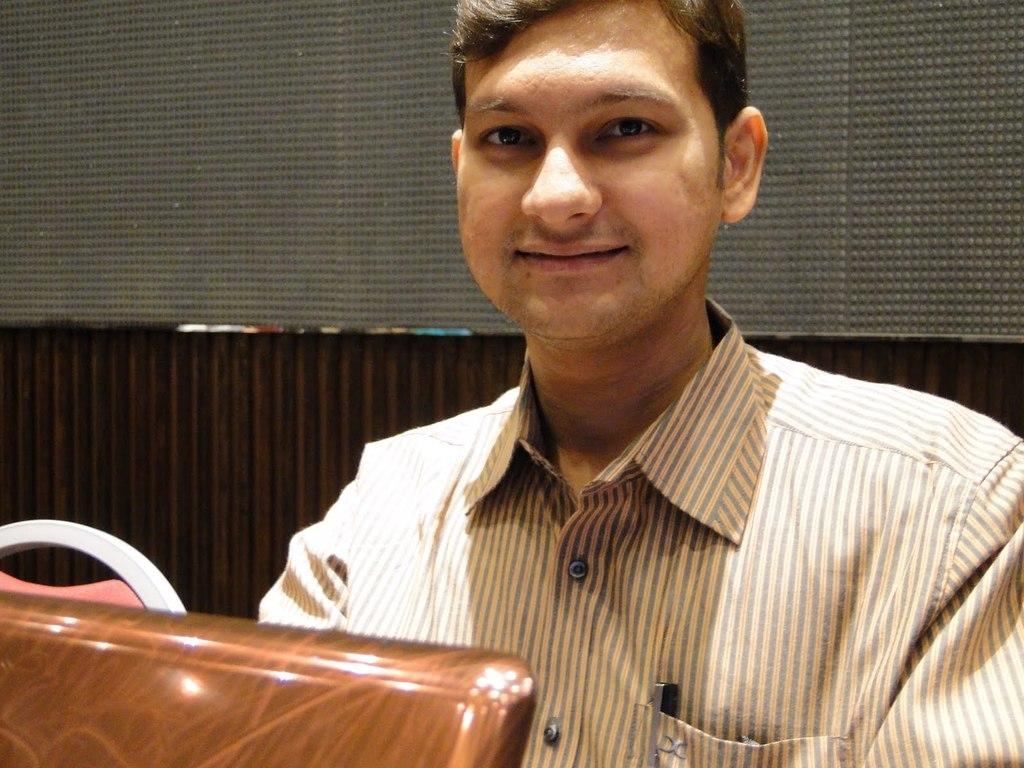What is the main subject of the image? The main subject of the image is a man sitting in a close-up picture. What can be observed about the man's attire? The man is wearing clothes. What is the man's facial expression in the image? The man is smiling. What type of material is visible in the background of the image? There is a wooden wall visible in the image. What type of structure can be seen in the image? There is a mesh in the image. What types of toys can be seen on the train in the image? There is no train or toys present in the image; it features a close-up picture of a man sitting and smiling. What memories does the man have of his childhood in the image? The image does not provide any information about the man's memories or childhood. 